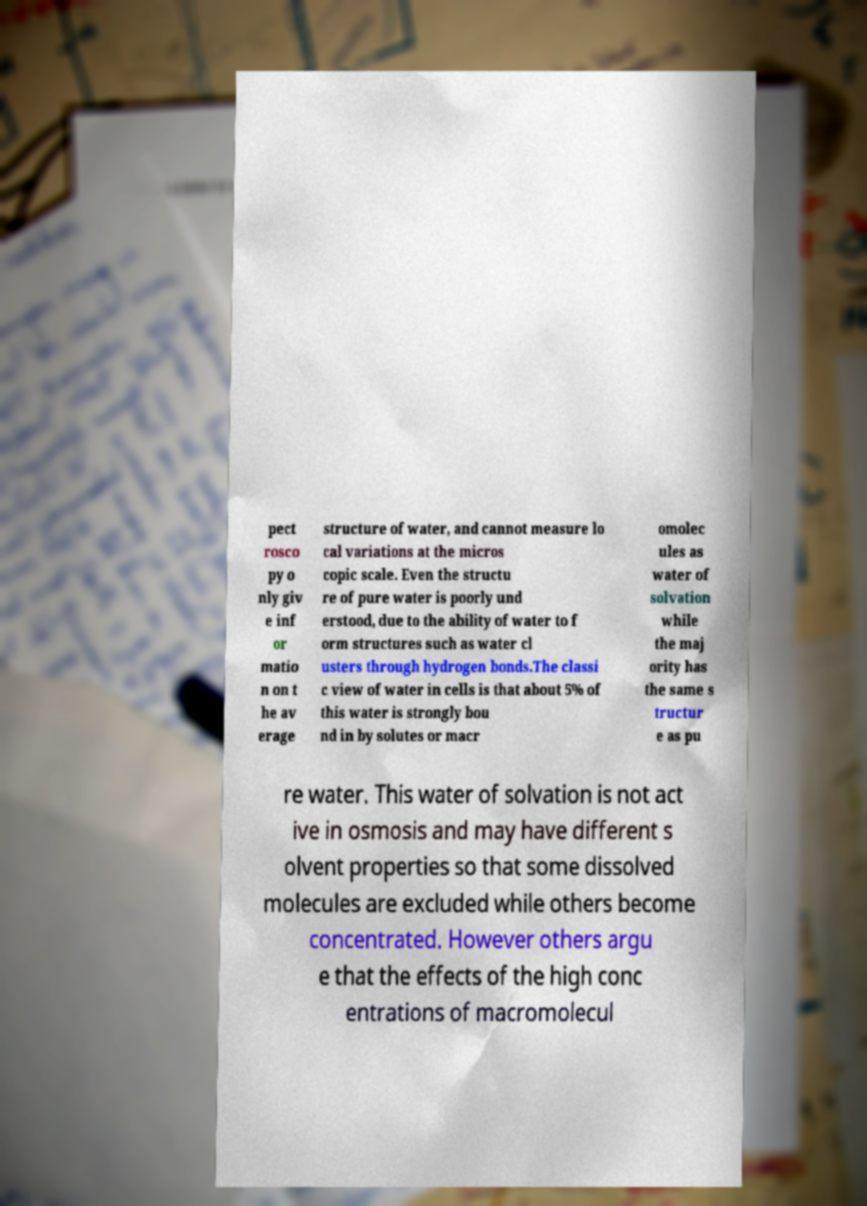Can you read and provide the text displayed in the image?This photo seems to have some interesting text. Can you extract and type it out for me? pect rosco py o nly giv e inf or matio n on t he av erage structure of water, and cannot measure lo cal variations at the micros copic scale. Even the structu re of pure water is poorly und erstood, due to the ability of water to f orm structures such as water cl usters through hydrogen bonds.The classi c view of water in cells is that about 5% of this water is strongly bou nd in by solutes or macr omolec ules as water of solvation while the maj ority has the same s tructur e as pu re water. This water of solvation is not act ive in osmosis and may have different s olvent properties so that some dissolved molecules are excluded while others become concentrated. However others argu e that the effects of the high conc entrations of macromolecul 